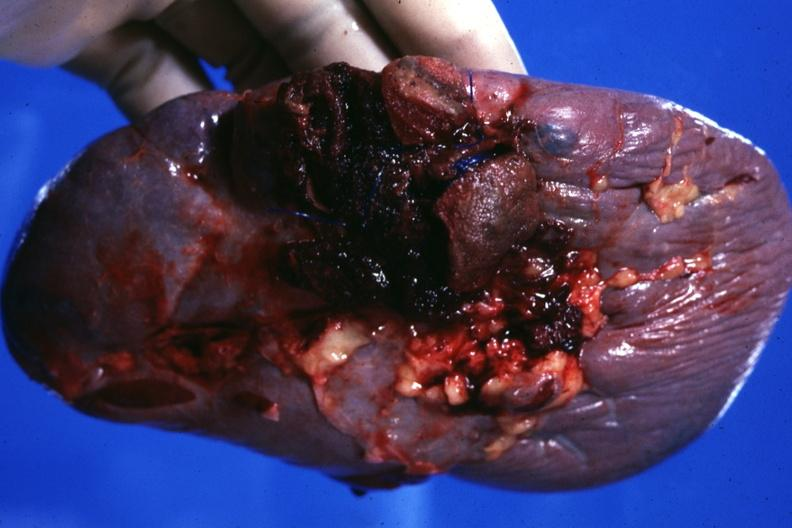what does this image show?
Answer the question using a single word or phrase. Close-up of ruptured area very good 